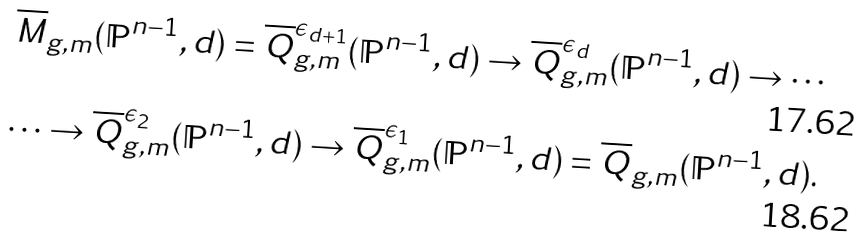Convert formula to latex. <formula><loc_0><loc_0><loc_500><loc_500>\overline { M } _ { g , m } ( \mathbb { P } ^ { n - 1 } , d ) = \overline { Q } _ { g , m } ^ { \epsilon _ { d + 1 } } ( \mathbb { P } ^ { n - 1 } , d ) \to \overline { Q } _ { g , m } ^ { \epsilon _ { d } } ( \mathbb { P } ^ { n - 1 } , d ) \to \cdots \\ \cdots \to \overline { Q } _ { g , m } ^ { \epsilon _ { 2 } } ( \mathbb { P } ^ { n - 1 } , d ) \to \overline { Q } _ { g , m } ^ { \epsilon _ { 1 } } ( \mathbb { P } ^ { n - 1 } , d ) = \overline { Q } _ { g , m } ( \mathbb { P } ^ { n - 1 } , d ) .</formula> 